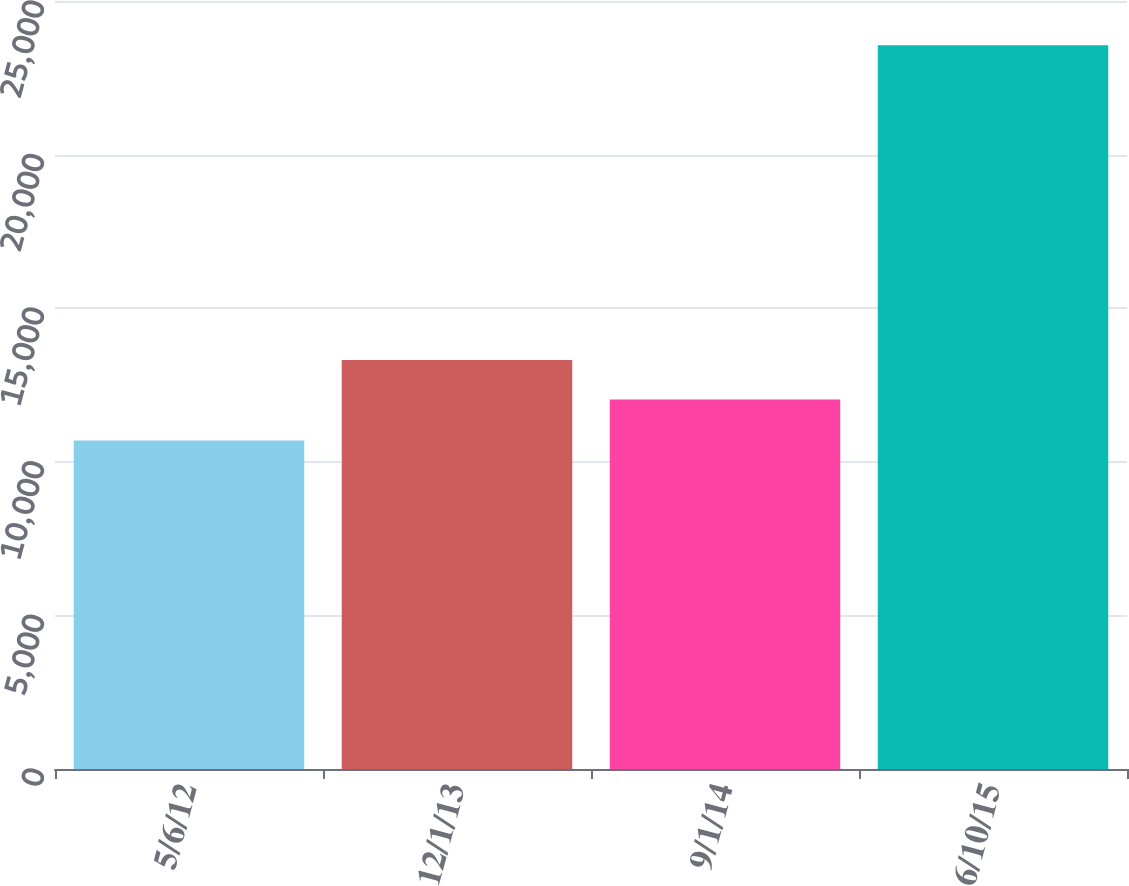Convert chart to OTSL. <chart><loc_0><loc_0><loc_500><loc_500><bar_chart><fcel>5/6/12<fcel>12/1/13<fcel>9/1/14<fcel>6/10/15<nl><fcel>10690<fcel>13316.7<fcel>12030<fcel>23557<nl></chart> 